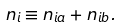<formula> <loc_0><loc_0><loc_500><loc_500>n _ { i } \equiv n _ { i a } + n _ { i b } .</formula> 